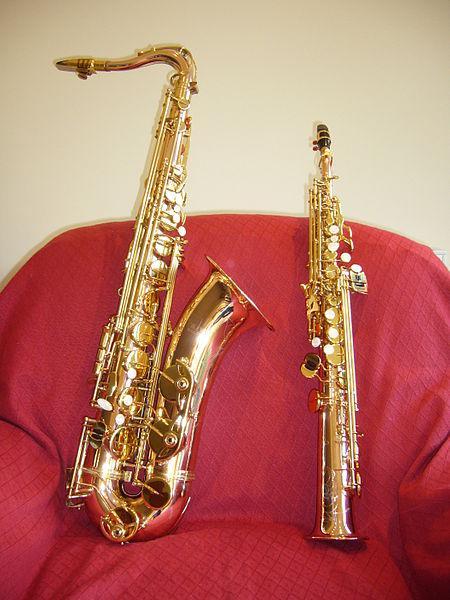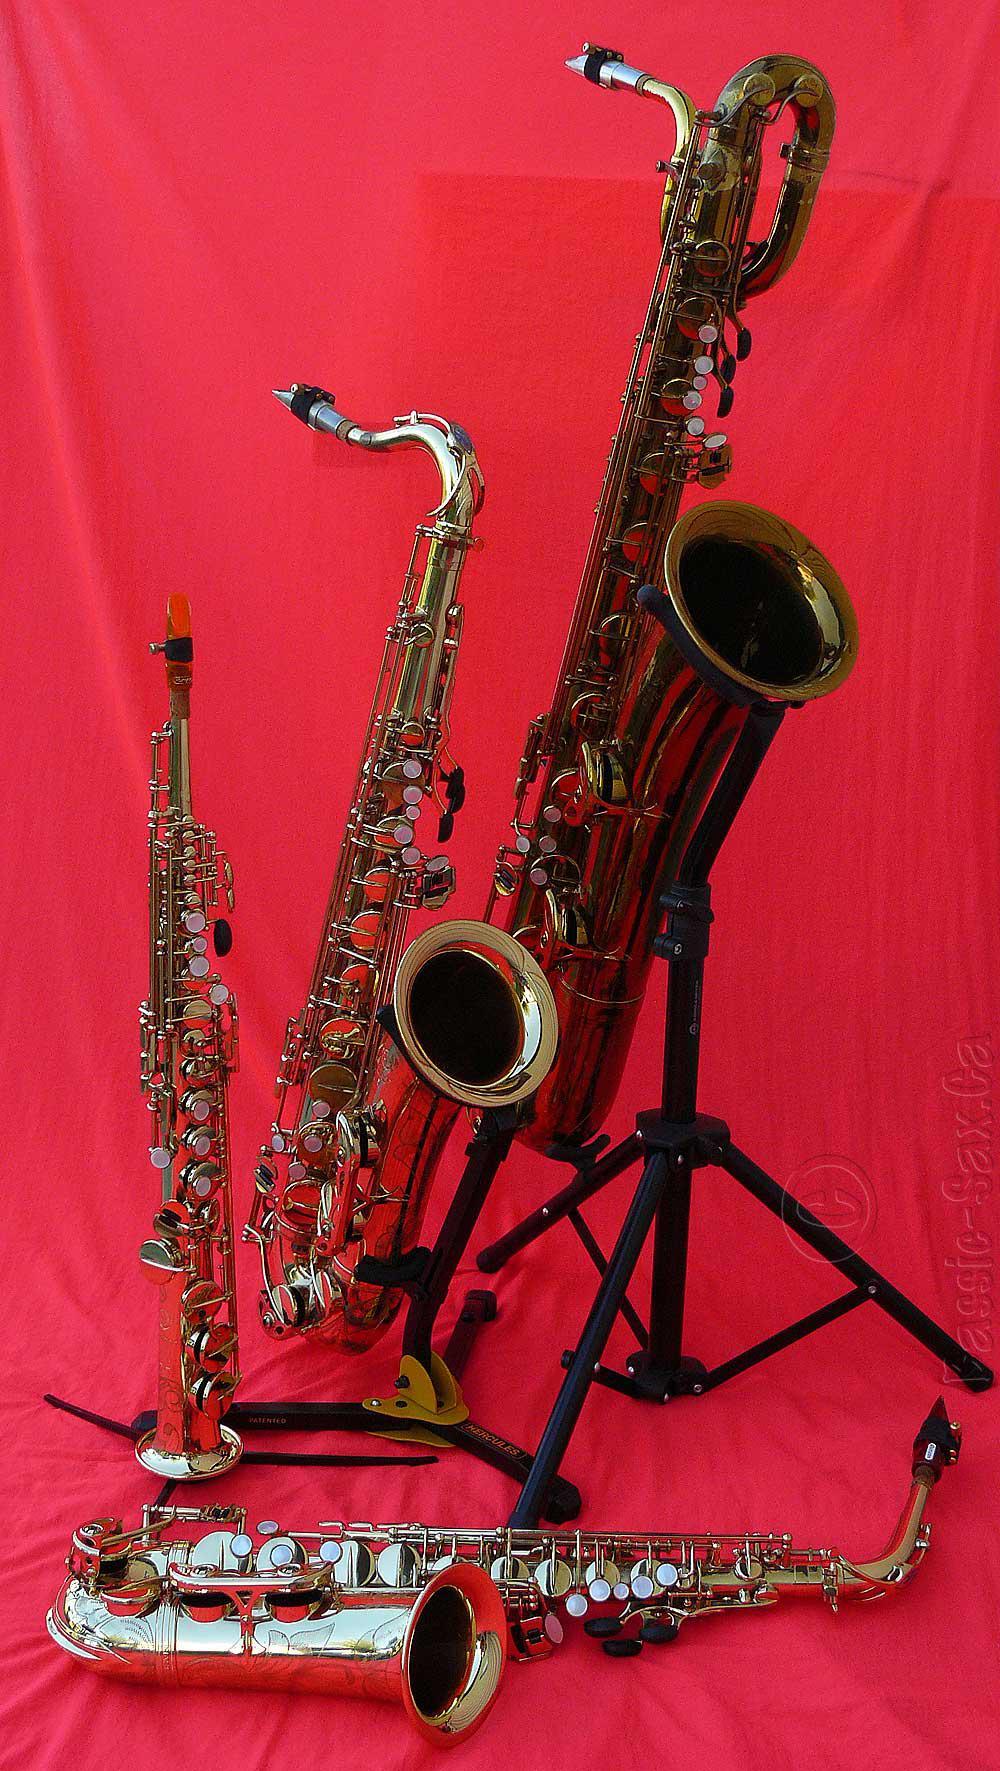The first image is the image on the left, the second image is the image on the right. Given the left and right images, does the statement "Has an image with more than one kind of saxophone." hold true? Answer yes or no. Yes. The first image is the image on the left, the second image is the image on the right. For the images shown, is this caption "At least one image shows a straight instrument displayed next to a saxophone with a curved bell and mouthpiece." true? Answer yes or no. Yes. 